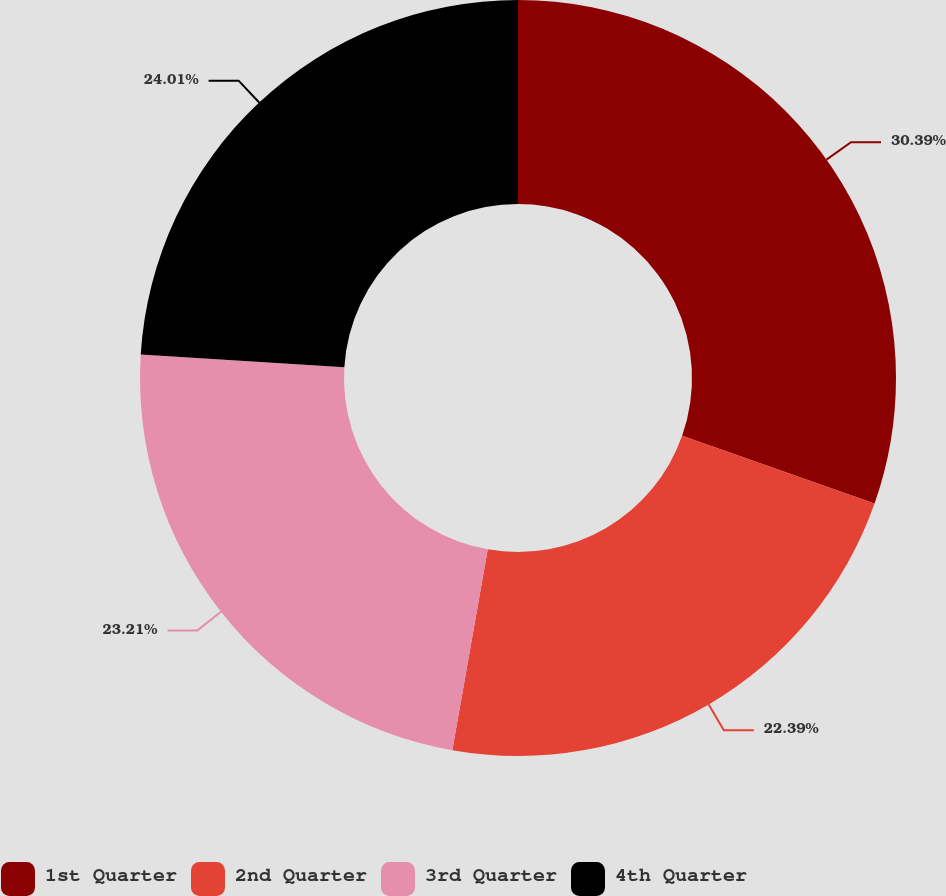Convert chart to OTSL. <chart><loc_0><loc_0><loc_500><loc_500><pie_chart><fcel>1st Quarter<fcel>2nd Quarter<fcel>3rd Quarter<fcel>4th Quarter<nl><fcel>30.39%<fcel>22.39%<fcel>23.21%<fcel>24.01%<nl></chart> 